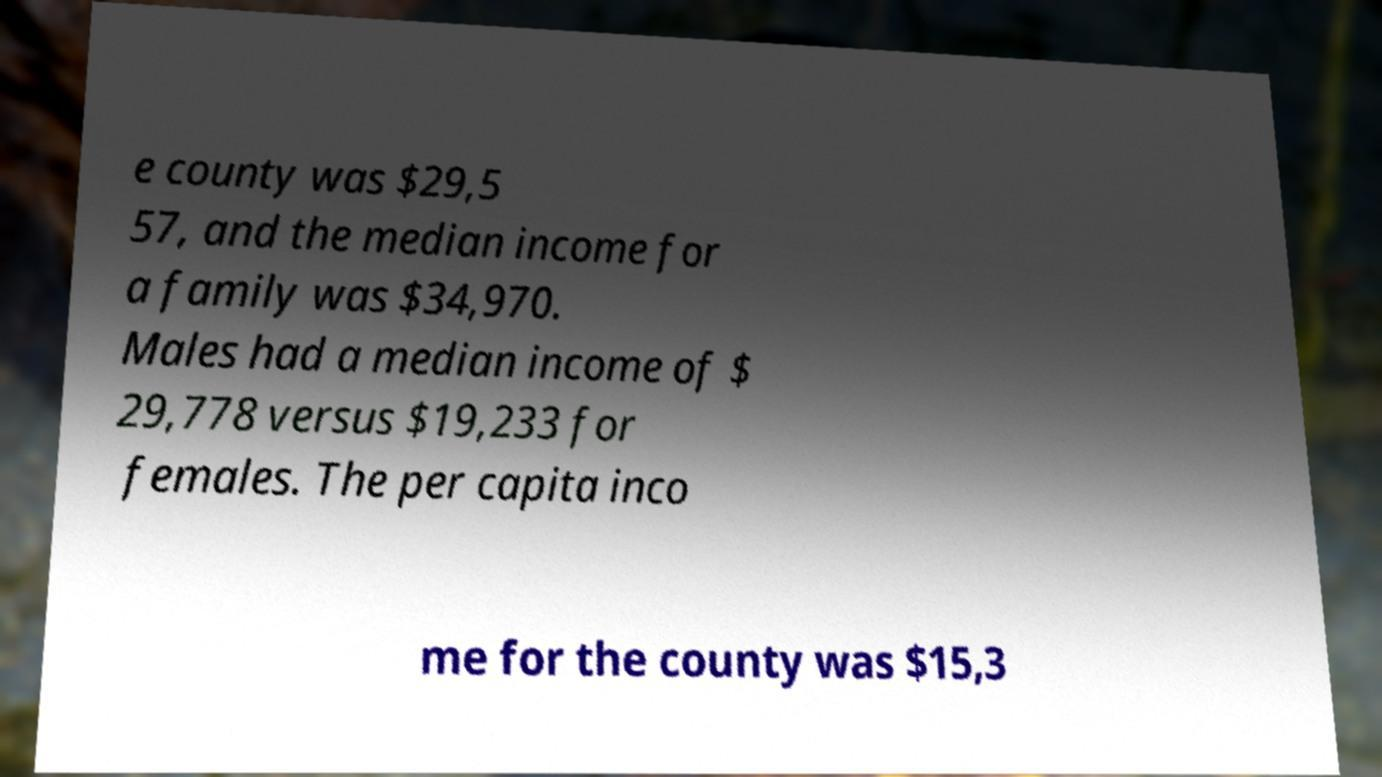Could you extract and type out the text from this image? e county was $29,5 57, and the median income for a family was $34,970. Males had a median income of $ 29,778 versus $19,233 for females. The per capita inco me for the county was $15,3 